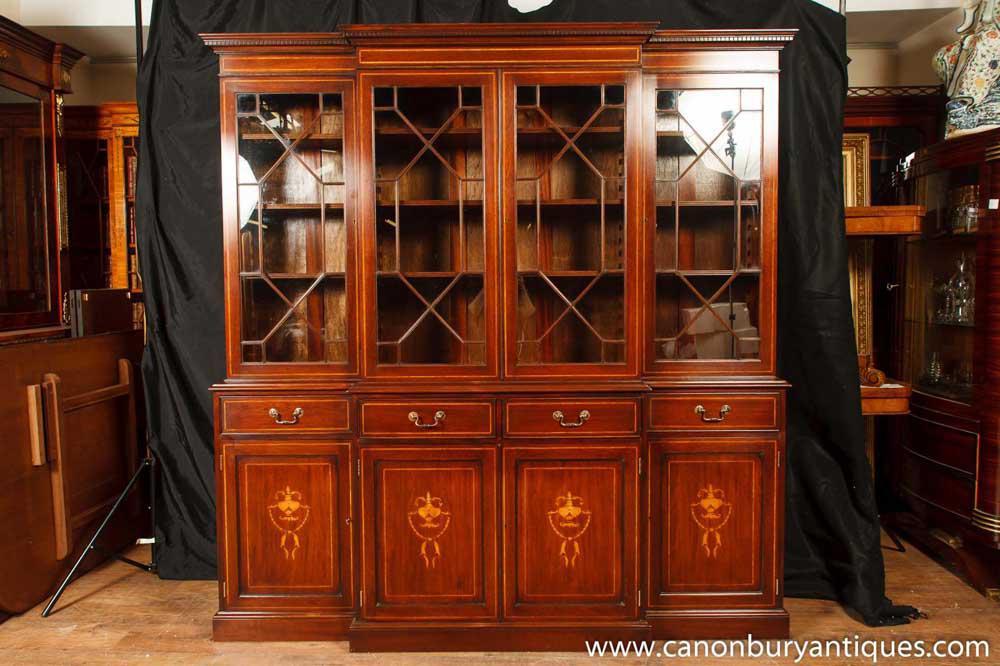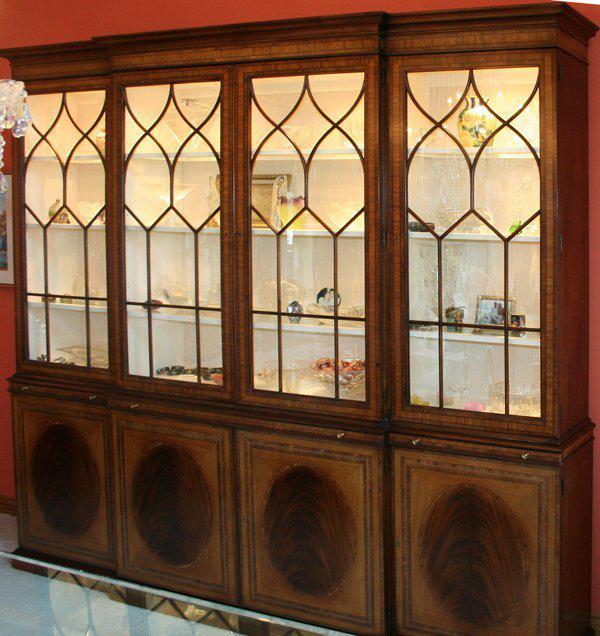The first image is the image on the left, the second image is the image on the right. Analyze the images presented: Is the assertion "There are four drawers on the cabinet in the image on the left." valid? Answer yes or no. Yes. 